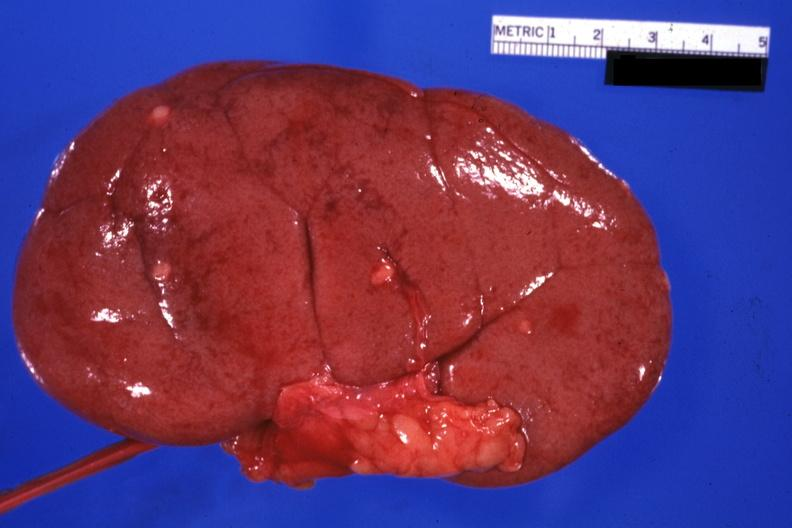s kidney present?
Answer the question using a single word or phrase. Yes 